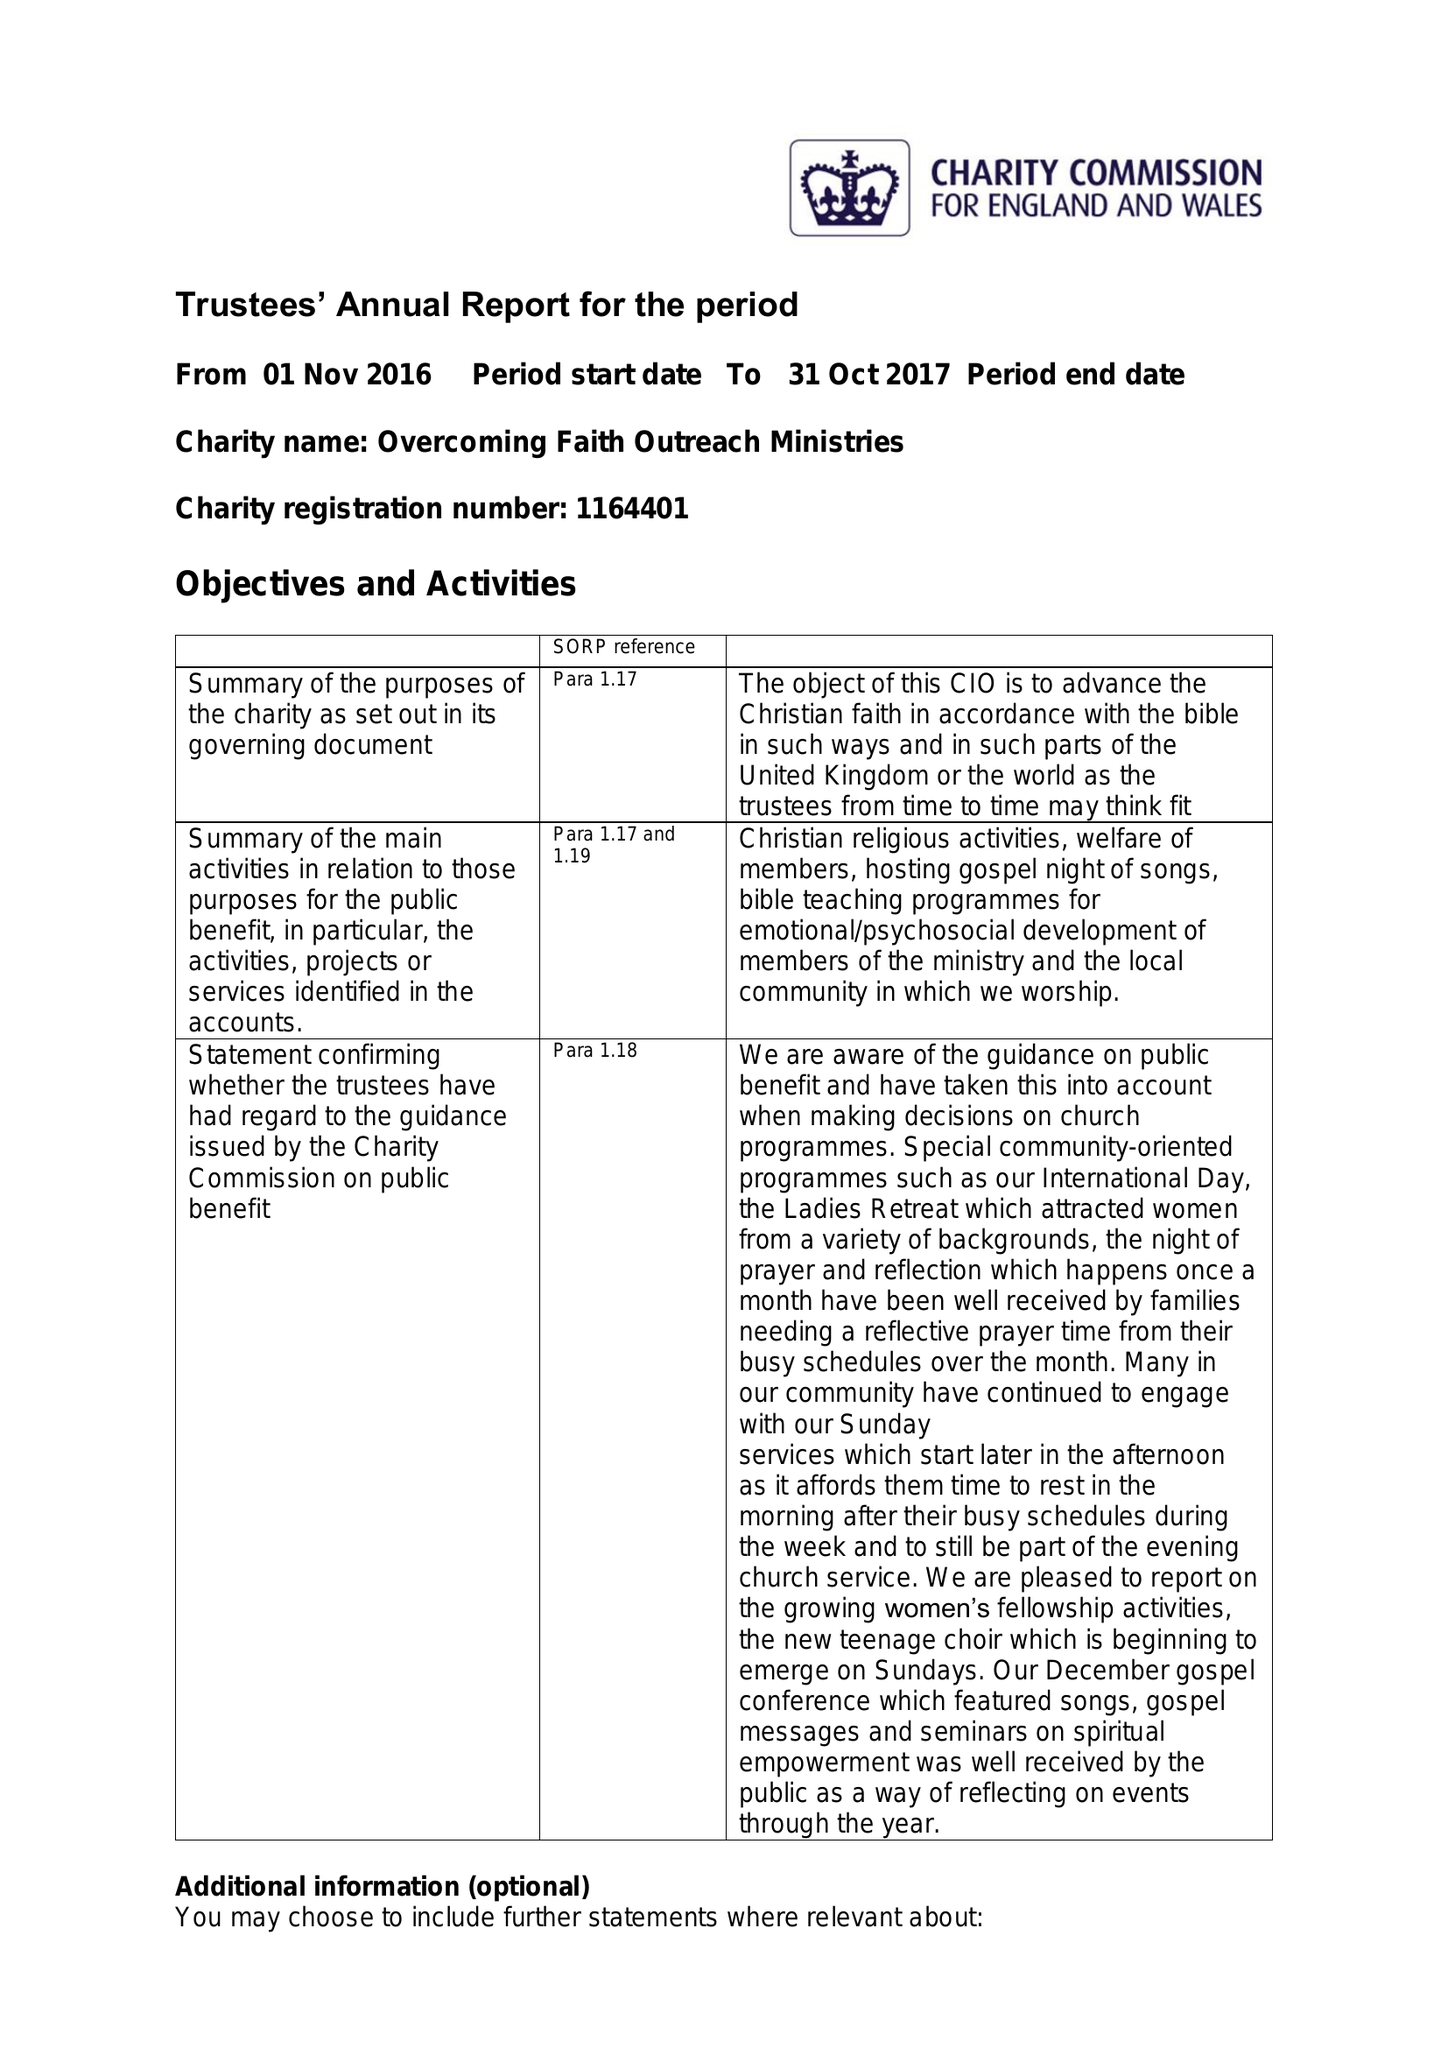What is the value for the charity_number?
Answer the question using a single word or phrase. 1164401 